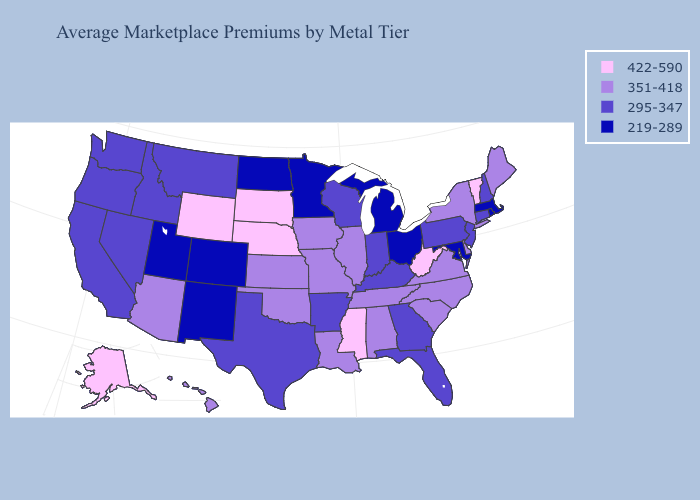What is the value of Texas?
Quick response, please. 295-347. What is the value of Utah?
Give a very brief answer. 219-289. Does Wisconsin have a lower value than Florida?
Concise answer only. No. What is the value of Alaska?
Quick response, please. 422-590. Which states have the lowest value in the USA?
Answer briefly. Colorado, Maryland, Massachusetts, Michigan, Minnesota, New Mexico, North Dakota, Ohio, Rhode Island, Utah. Among the states that border West Virginia , which have the highest value?
Write a very short answer. Virginia. Name the states that have a value in the range 295-347?
Concise answer only. Arkansas, California, Connecticut, Florida, Georgia, Idaho, Indiana, Kentucky, Montana, Nevada, New Hampshire, New Jersey, Oregon, Pennsylvania, Texas, Washington, Wisconsin. Is the legend a continuous bar?
Give a very brief answer. No. Does Arizona have the highest value in the West?
Short answer required. No. Does Massachusetts have the lowest value in the USA?
Quick response, please. Yes. What is the highest value in the South ?
Write a very short answer. 422-590. Which states hav the highest value in the South?
Quick response, please. Mississippi, West Virginia. Among the states that border West Virginia , does Ohio have the lowest value?
Give a very brief answer. Yes. Name the states that have a value in the range 295-347?
Write a very short answer. Arkansas, California, Connecticut, Florida, Georgia, Idaho, Indiana, Kentucky, Montana, Nevada, New Hampshire, New Jersey, Oregon, Pennsylvania, Texas, Washington, Wisconsin. 